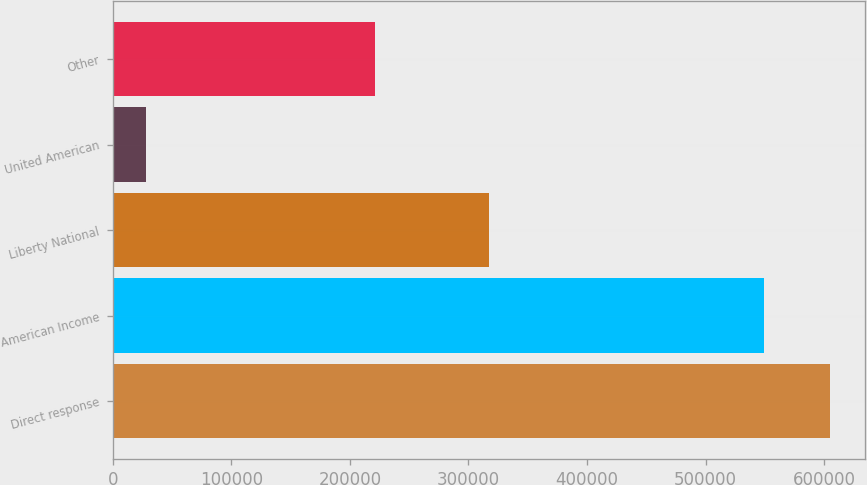Convert chart to OTSL. <chart><loc_0><loc_0><loc_500><loc_500><bar_chart><fcel>Direct response<fcel>American Income<fcel>Liberty National<fcel>United American<fcel>Other<nl><fcel>604588<fcel>549540<fcel>317413<fcel>27740<fcel>221486<nl></chart> 